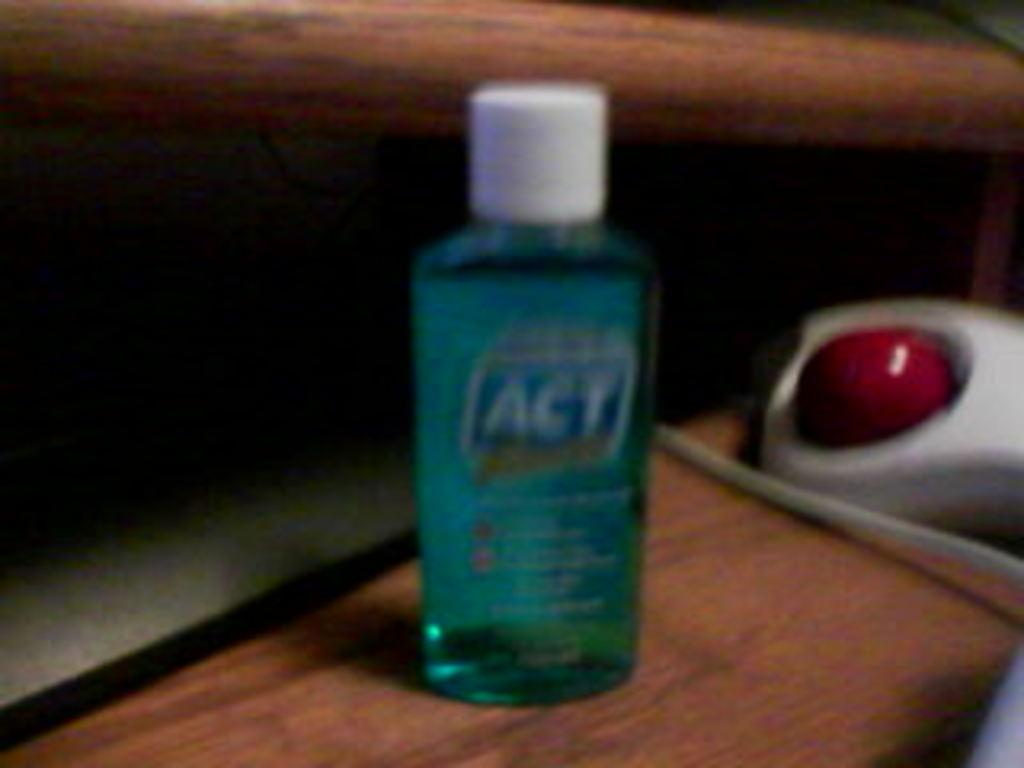<image>
Write a terse but informative summary of the picture. A bottle of ACT mouth wash is on a wooden surface. 